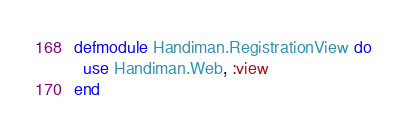<code> <loc_0><loc_0><loc_500><loc_500><_Elixir_>defmodule Handiman.RegistrationView do
  use Handiman.Web, :view
end
</code> 